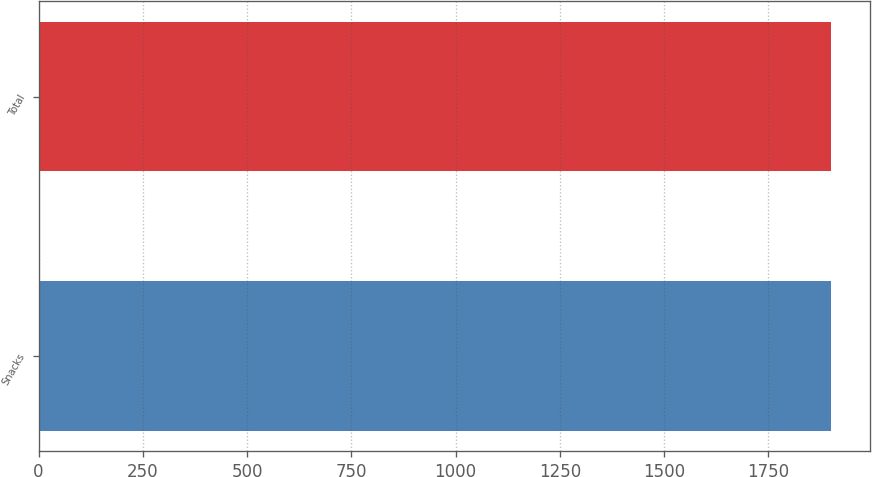<chart> <loc_0><loc_0><loc_500><loc_500><bar_chart><fcel>Snacks<fcel>Total<nl><fcel>1899<fcel>1899.1<nl></chart> 